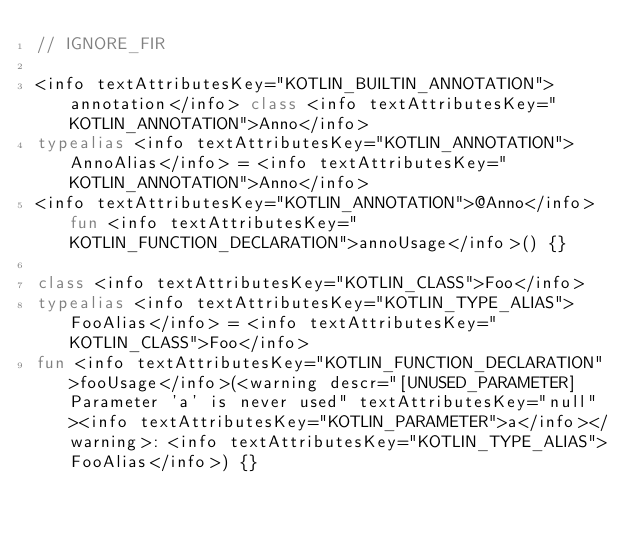<code> <loc_0><loc_0><loc_500><loc_500><_Kotlin_>// IGNORE_FIR

<info textAttributesKey="KOTLIN_BUILTIN_ANNOTATION">annotation</info> class <info textAttributesKey="KOTLIN_ANNOTATION">Anno</info>
typealias <info textAttributesKey="KOTLIN_ANNOTATION">AnnoAlias</info> = <info textAttributesKey="KOTLIN_ANNOTATION">Anno</info>
<info textAttributesKey="KOTLIN_ANNOTATION">@Anno</info> fun <info textAttributesKey="KOTLIN_FUNCTION_DECLARATION">annoUsage</info>() {}

class <info textAttributesKey="KOTLIN_CLASS">Foo</info>
typealias <info textAttributesKey="KOTLIN_TYPE_ALIAS">FooAlias</info> = <info textAttributesKey="KOTLIN_CLASS">Foo</info>
fun <info textAttributesKey="KOTLIN_FUNCTION_DECLARATION">fooUsage</info>(<warning descr="[UNUSED_PARAMETER] Parameter 'a' is never used" textAttributesKey="null"><info textAttributesKey="KOTLIN_PARAMETER">a</info></warning>: <info textAttributesKey="KOTLIN_TYPE_ALIAS">FooAlias</info>) {}</code> 